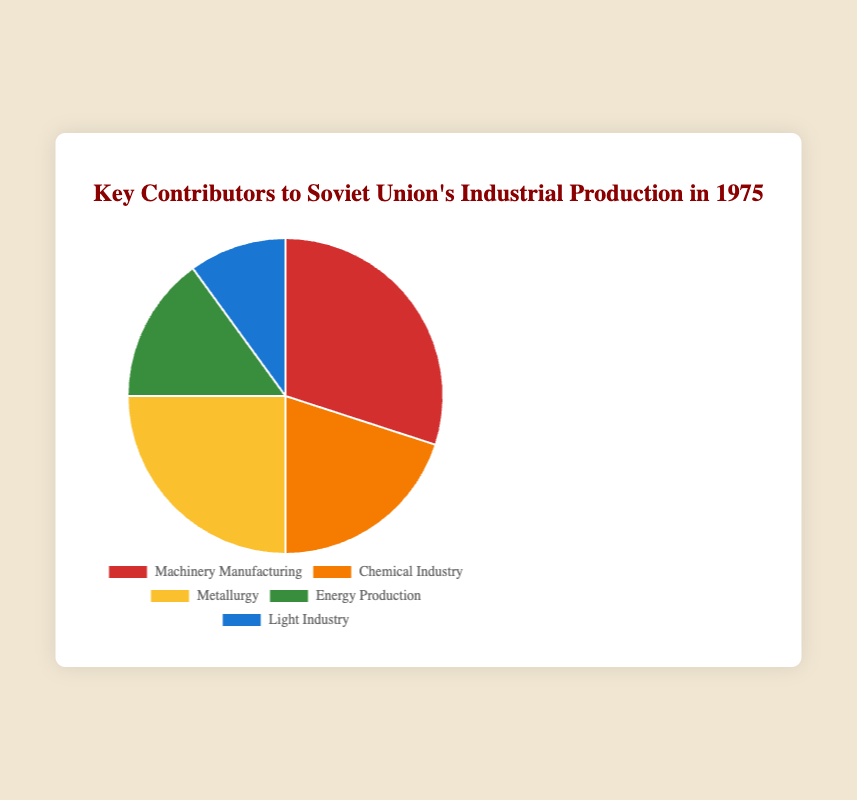Which sector contributed the most to the Soviet Union's industrial production in 1975? The sector with the highest percentage is the key contributor. By looking at the pie chart, we can see that Machinery Manufacturing has the highest percentage.
Answer: Machinery Manufacturing Which sector had the lowest contribution to the Soviet Union's industrial production in 1975? The sector with the smallest percentage is the lowest contributor. By observing the pie chart, Light Industry has the lowest percentage.
Answer: Light Industry How much more did the Metallurgy sector contribute compared to the Light Industry sector? To find the difference, subtract Light Industry's percentage from Metallurgy's percentage: 25% - 10% = 15%.
Answer: 15% What percentage of the Soviet Union's industrial production in 1975 was contributed by the Energy Production and Chemical Industry sectors combined? Add the percentages of the Energy Production and Chemical Industry sectors: 15% + 20% = 35%.
Answer: 35% How much more did the Machinery Manufacturing sector contribute compared to the Energy Production sector? Subtract Energy Production's percentage from Machinery Manufacturing's percentage: 30% - 15% = 15%.
Answer: 15% Arrange the sectors in descending order of their contribution to Soviet Union's industrial production in 1975. Orders the sectors by their percentage from highest to lowest: Machinery Manufacturing (30%), Metallurgy (25%), Chemical Industry (20%), Energy Production (15%), Light Industry (10%).
Answer: Machinery Manufacturing > Metallurgy > Chemical Industry > Energy Production > Light Industry How does the contribution of the Chemical Industry compare to the Metallurgy sector? The Chemical Industry's percentage (20%) is less than the Metallurgy's percentage (25%).
Answer: Less than What is the combined percentage contribution of the Light Industry and Energy Production sectors? Add the percentages of Light Industry and Energy Production sectors: 10% + 15% = 25%.
Answer: 25% If the percentages of Chemical Industry and Metallurgy sectors were swapped, what would be the new highest contributing sector? Currently, Machinery Manufacturing is at 30%. Swapping the percentages of Chemical Industry (20%) and Metallurgy (25%), would not change the highest sector since 30% is still the highest.
Answer: Machinery Manufacturing 